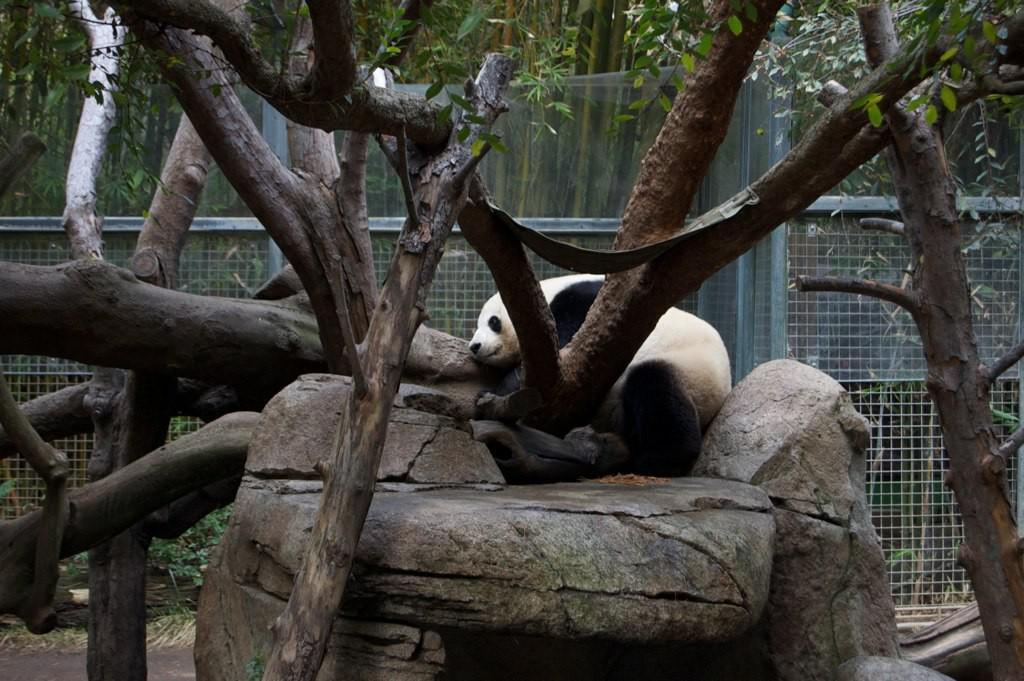What animal is sitting on a rock in the image? There is a panda sitting on a rock in the image. What type of vegetation can be seen in the image? There are trees in the image. What is visible in the background of the image? There is a fence in the background of the image. What is located behind the fence in the image? There are trees behind the fence in the image. What type of plants are at the bottom of the image? There are plants at the bottom of the image. What type of loaf is being used to perform an operation on the panda in the image? There is no loaf or operation being performed on the panda in the image; it is simply sitting on a rock. 